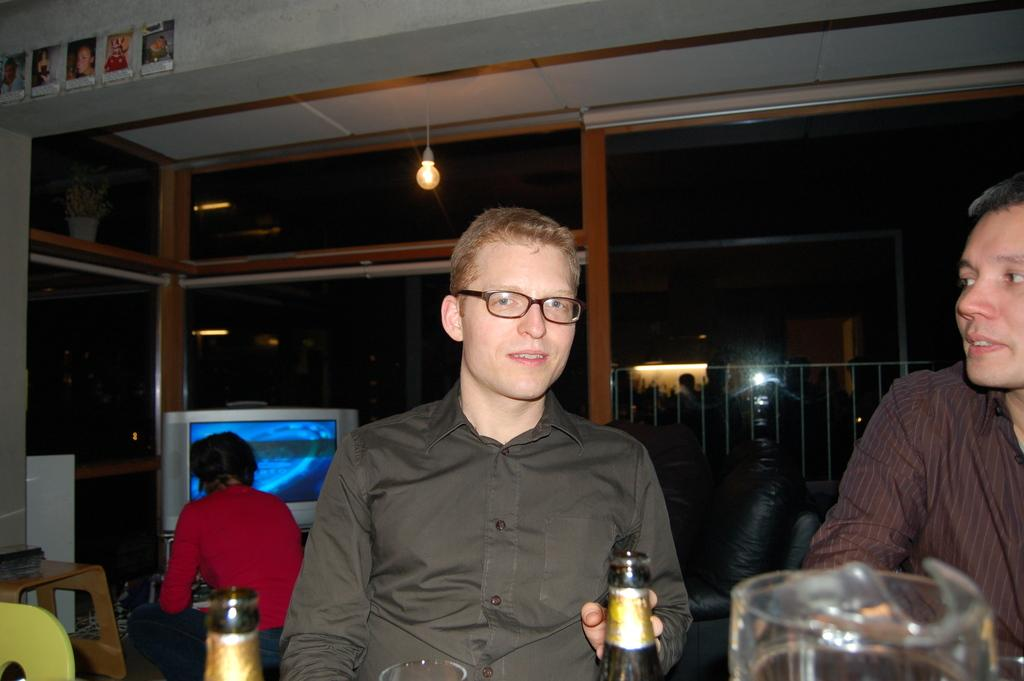How many people are present in the image? There are two people in the image. What objects are in front of the people? There are bottles and a glass in front of the people. Can you describe the background of the image? In the background of the image, there is a person, a television, lights, and some objects. What type of organization is depicted in the picture? There is no organization depicted in the image; it features two people, objects in front of them, and elements in the background. Can you tell me how many combs are visible in the image? There are no combs present in the image. 